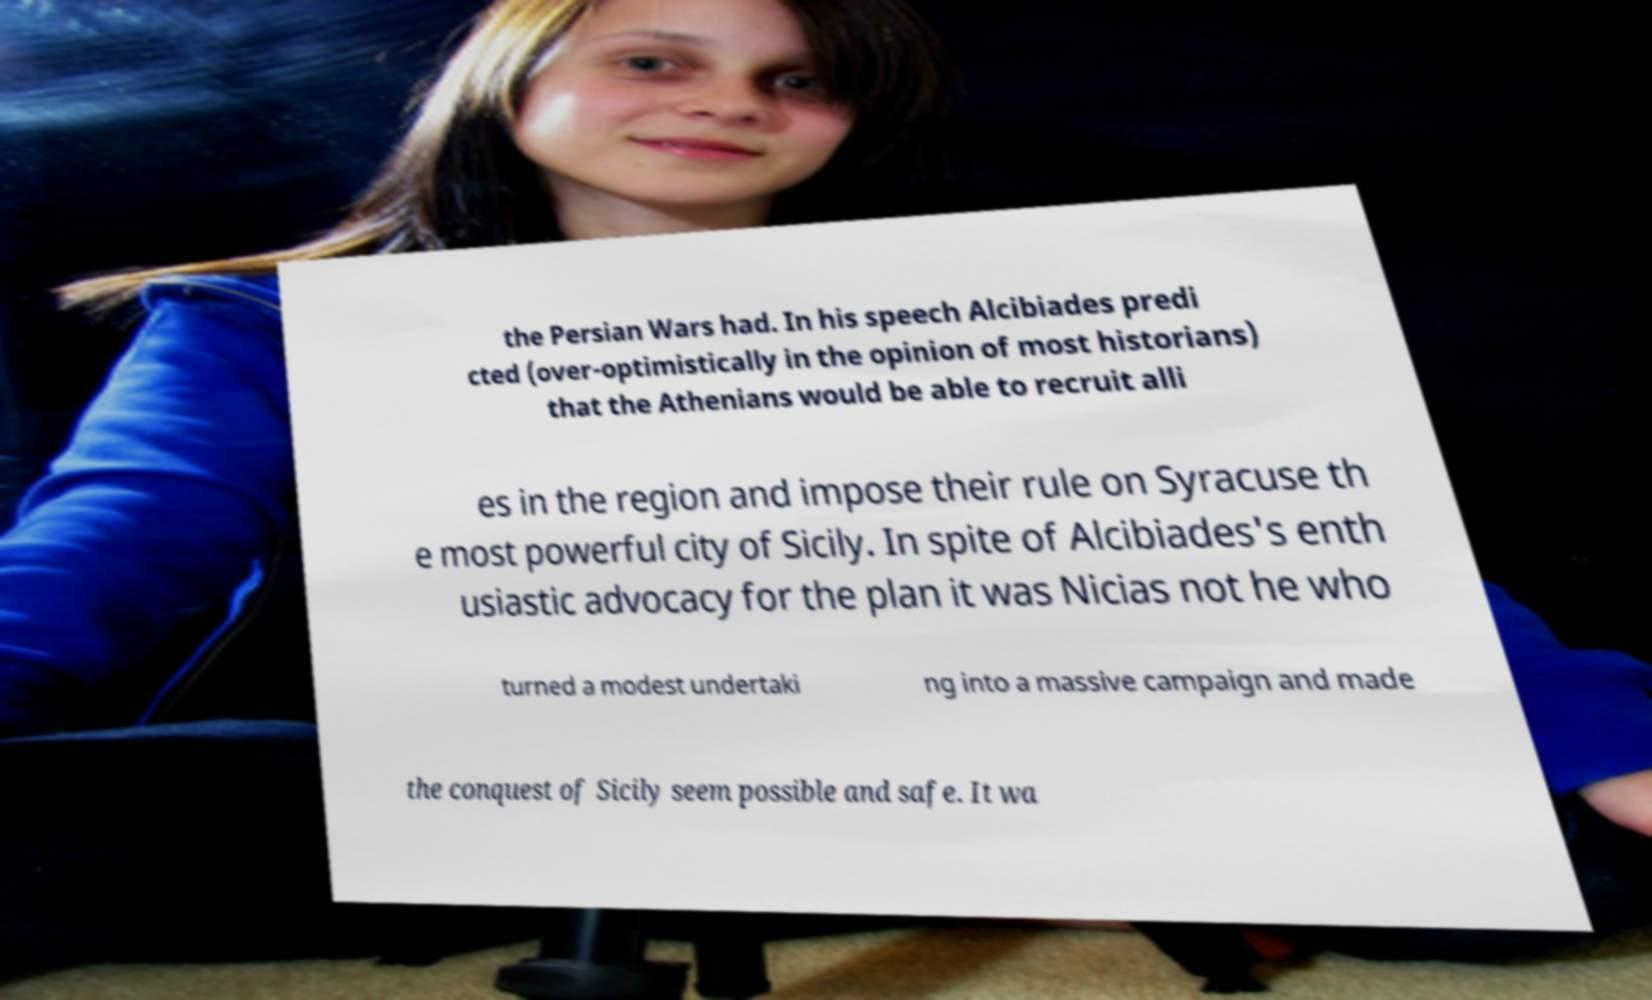Can you read and provide the text displayed in the image?This photo seems to have some interesting text. Can you extract and type it out for me? the Persian Wars had. In his speech Alcibiades predi cted (over-optimistically in the opinion of most historians) that the Athenians would be able to recruit alli es in the region and impose their rule on Syracuse th e most powerful city of Sicily. In spite of Alcibiades's enth usiastic advocacy for the plan it was Nicias not he who turned a modest undertaki ng into a massive campaign and made the conquest of Sicily seem possible and safe. It wa 